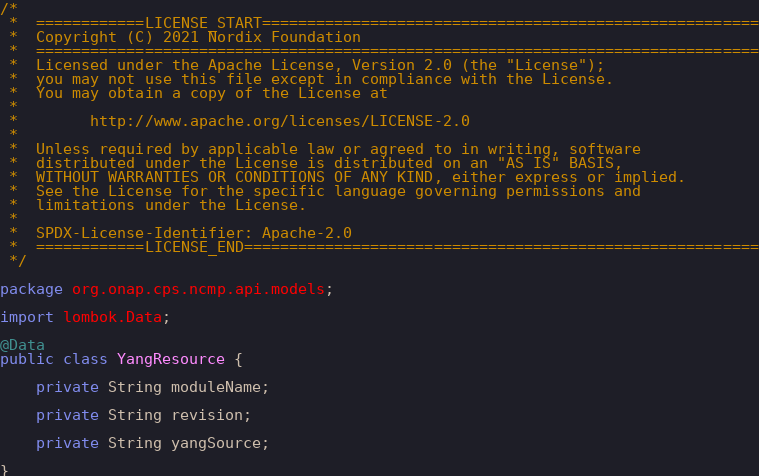Convert code to text. <code><loc_0><loc_0><loc_500><loc_500><_Java_>/*
 *  ============LICENSE_START=======================================================
 *  Copyright (C) 2021 Nordix Foundation
 *  ================================================================================
 *  Licensed under the Apache License, Version 2.0 (the "License");
 *  you may not use this file except in compliance with the License.
 *  You may obtain a copy of the License at
 *
 *        http://www.apache.org/licenses/LICENSE-2.0
 *
 *  Unless required by applicable law or agreed to in writing, software
 *  distributed under the License is distributed on an "AS IS" BASIS,
 *  WITHOUT WARRANTIES OR CONDITIONS OF ANY KIND, either express or implied.
 *  See the License for the specific language governing permissions and
 *  limitations under the License.
 *
 *  SPDX-License-Identifier: Apache-2.0
 *  ============LICENSE_END=========================================================
 */

package org.onap.cps.ncmp.api.models;

import lombok.Data;

@Data
public class YangResource {

    private String moduleName;

    private String revision;

    private String yangSource;

}
</code> 